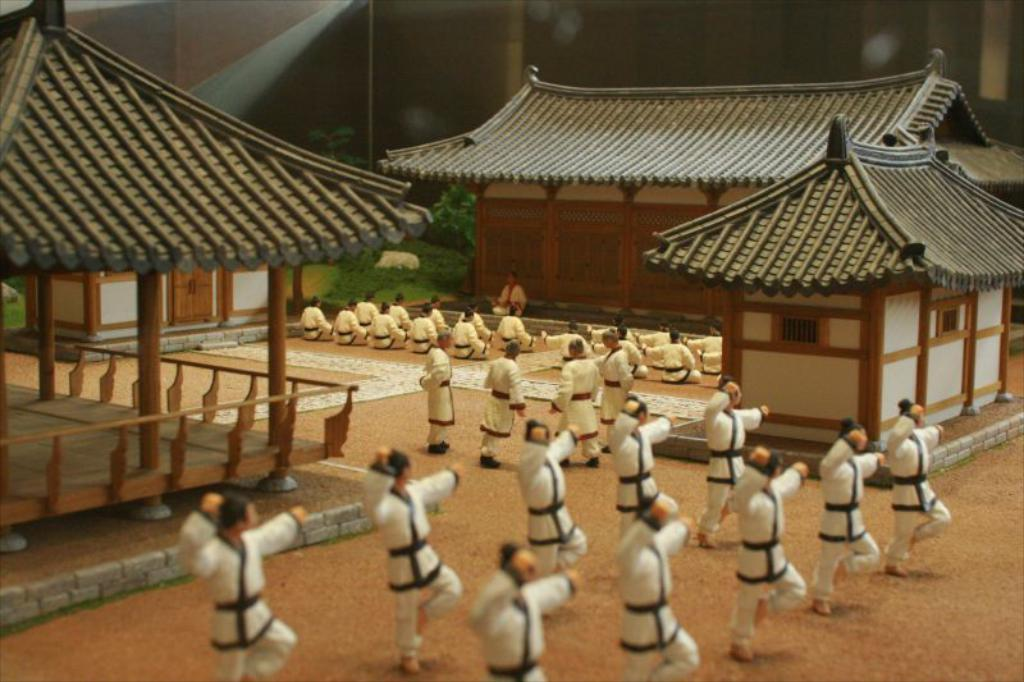What type of toys can be seen in the image? There are toy houses and men toys in the image. Can you describe the toy houses in the image? The toy houses are small and likely made of plastic or other materials. What other types of toys are present in the image besides the toy houses? There are men toys in the image. How does the growth of the toy houses affect the edge of the image? The growth of the toy houses does not affect the edge of the image, as the toys are not alive and do not grow. 